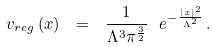<formula> <loc_0><loc_0><loc_500><loc_500>v _ { r e g } \left ( x \right ) \ = \ \frac { 1 } { \Lambda ^ { 3 } \pi ^ { \frac { 3 } { 2 } } } \ e ^ { - \frac { | x | ^ { 2 } } { \Lambda ^ { 2 } } } \, . \,</formula> 